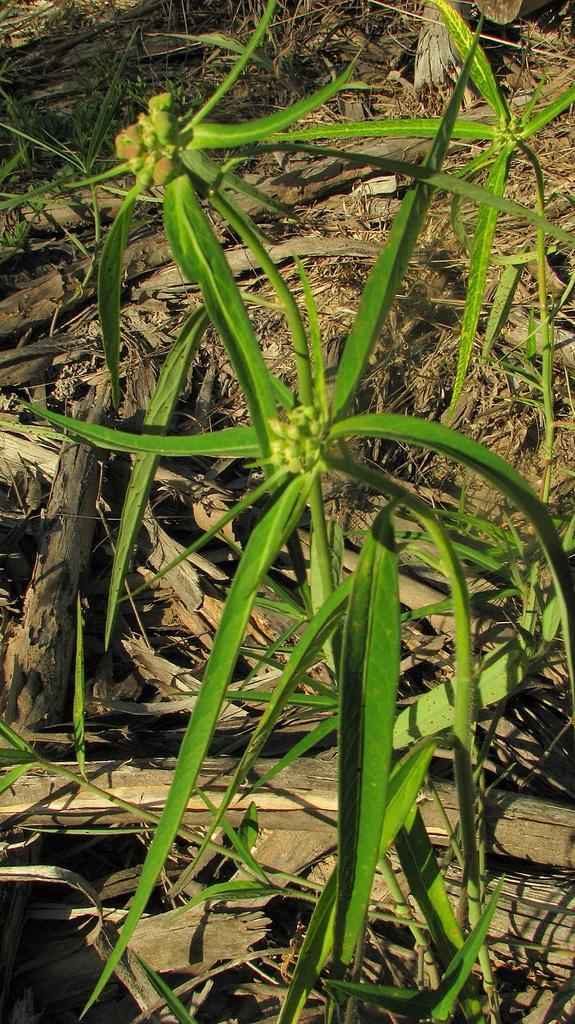What type of plant material is present in the image? There are green leaves on stems and dry leaves visible in the image. What other objects can be seen on the ground in the image? Wooden sticks are present on the ground in the image. What type of pies are being served at the picnic in the image? There is no picnic or pies present in the image; it features green leaves on stems, dry leaves, and wooden sticks on the ground. 